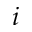<formula> <loc_0><loc_0><loc_500><loc_500>i</formula> 